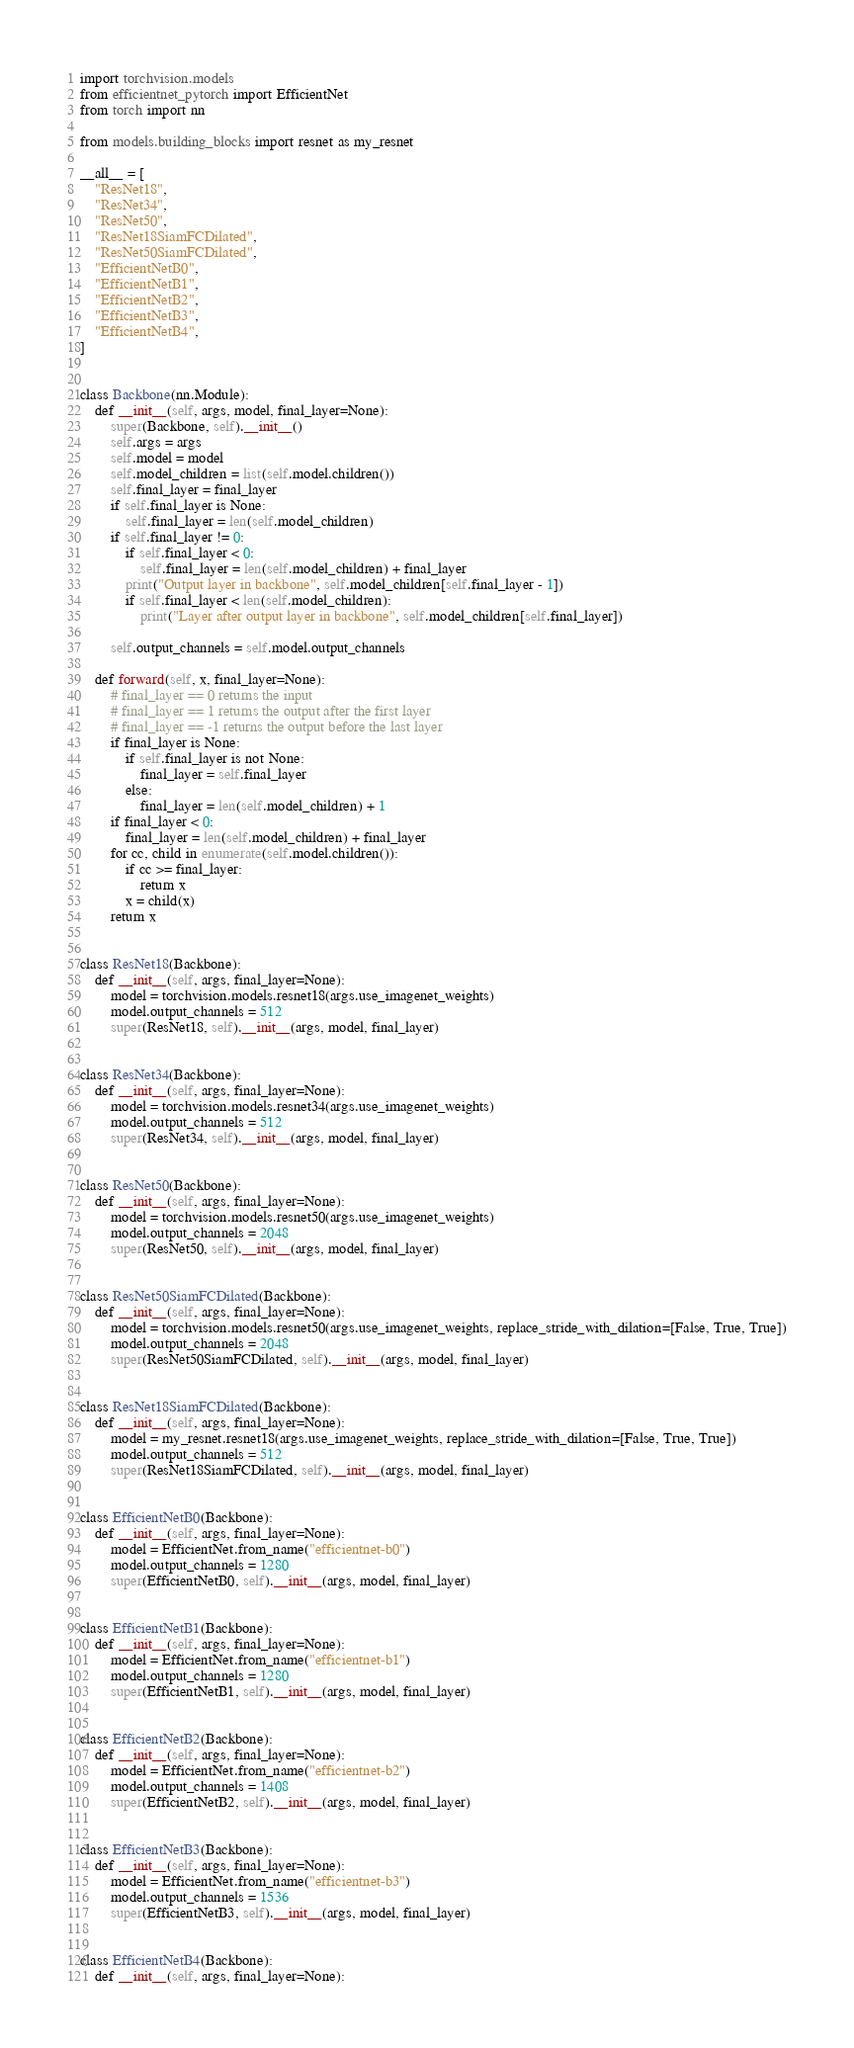<code> <loc_0><loc_0><loc_500><loc_500><_Python_>import torchvision.models
from efficientnet_pytorch import EfficientNet
from torch import nn

from models.building_blocks import resnet as my_resnet

__all__ = [
    "ResNet18",
    "ResNet34",
    "ResNet50",
    "ResNet18SiamFCDilated",
    "ResNet50SiamFCDilated",
    "EfficientNetB0",
    "EfficientNetB1",
    "EfficientNetB2",
    "EfficientNetB3",
    "EfficientNetB4",
]


class Backbone(nn.Module):
    def __init__(self, args, model, final_layer=None):
        super(Backbone, self).__init__()
        self.args = args
        self.model = model
        self.model_children = list(self.model.children())
        self.final_layer = final_layer
        if self.final_layer is None:
            self.final_layer = len(self.model_children)
        if self.final_layer != 0:
            if self.final_layer < 0:
                self.final_layer = len(self.model_children) + final_layer
            print("Output layer in backbone", self.model_children[self.final_layer - 1])
            if self.final_layer < len(self.model_children):
                print("Layer after output layer in backbone", self.model_children[self.final_layer])

        self.output_channels = self.model.output_channels

    def forward(self, x, final_layer=None):
        # final_layer == 0 returns the input
        # final_layer == 1 returns the output after the first layer
        # final_layer == -1 returns the output before the last layer
        if final_layer is None:
            if self.final_layer is not None:
                final_layer = self.final_layer
            else:
                final_layer = len(self.model_children) + 1
        if final_layer < 0:
            final_layer = len(self.model_children) + final_layer
        for cc, child in enumerate(self.model.children()):
            if cc >= final_layer:
                return x
            x = child(x)
        return x


class ResNet18(Backbone):
    def __init__(self, args, final_layer=None):
        model = torchvision.models.resnet18(args.use_imagenet_weights)
        model.output_channels = 512
        super(ResNet18, self).__init__(args, model, final_layer)


class ResNet34(Backbone):
    def __init__(self, args, final_layer=None):
        model = torchvision.models.resnet34(args.use_imagenet_weights)
        model.output_channels = 512
        super(ResNet34, self).__init__(args, model, final_layer)


class ResNet50(Backbone):
    def __init__(self, args, final_layer=None):
        model = torchvision.models.resnet50(args.use_imagenet_weights)
        model.output_channels = 2048
        super(ResNet50, self).__init__(args, model, final_layer)


class ResNet50SiamFCDilated(Backbone):
    def __init__(self, args, final_layer=None):
        model = torchvision.models.resnet50(args.use_imagenet_weights, replace_stride_with_dilation=[False, True, True])
        model.output_channels = 2048
        super(ResNet50SiamFCDilated, self).__init__(args, model, final_layer)


class ResNet18SiamFCDilated(Backbone):
    def __init__(self, args, final_layer=None):
        model = my_resnet.resnet18(args.use_imagenet_weights, replace_stride_with_dilation=[False, True, True])
        model.output_channels = 512
        super(ResNet18SiamFCDilated, self).__init__(args, model, final_layer)


class EfficientNetB0(Backbone):
    def __init__(self, args, final_layer=None):
        model = EfficientNet.from_name("efficientnet-b0")
        model.output_channels = 1280
        super(EfficientNetB0, self).__init__(args, model, final_layer)


class EfficientNetB1(Backbone):
    def __init__(self, args, final_layer=None):
        model = EfficientNet.from_name("efficientnet-b1")
        model.output_channels = 1280
        super(EfficientNetB1, self).__init__(args, model, final_layer)


class EfficientNetB2(Backbone):
    def __init__(self, args, final_layer=None):
        model = EfficientNet.from_name("efficientnet-b2")
        model.output_channels = 1408
        super(EfficientNetB2, self).__init__(args, model, final_layer)


class EfficientNetB3(Backbone):
    def __init__(self, args, final_layer=None):
        model = EfficientNet.from_name("efficientnet-b3")
        model.output_channels = 1536
        super(EfficientNetB3, self).__init__(args, model, final_layer)


class EfficientNetB4(Backbone):
    def __init__(self, args, final_layer=None):</code> 